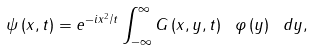Convert formula to latex. <formula><loc_0><loc_0><loc_500><loc_500>\psi \left ( x , t \right ) = e ^ { - i x ^ { 2 } / t } \int _ { - \infty } ^ { \infty } G \left ( x , y , t \right ) \ \varphi \left ( y \right ) \ d y ,</formula> 